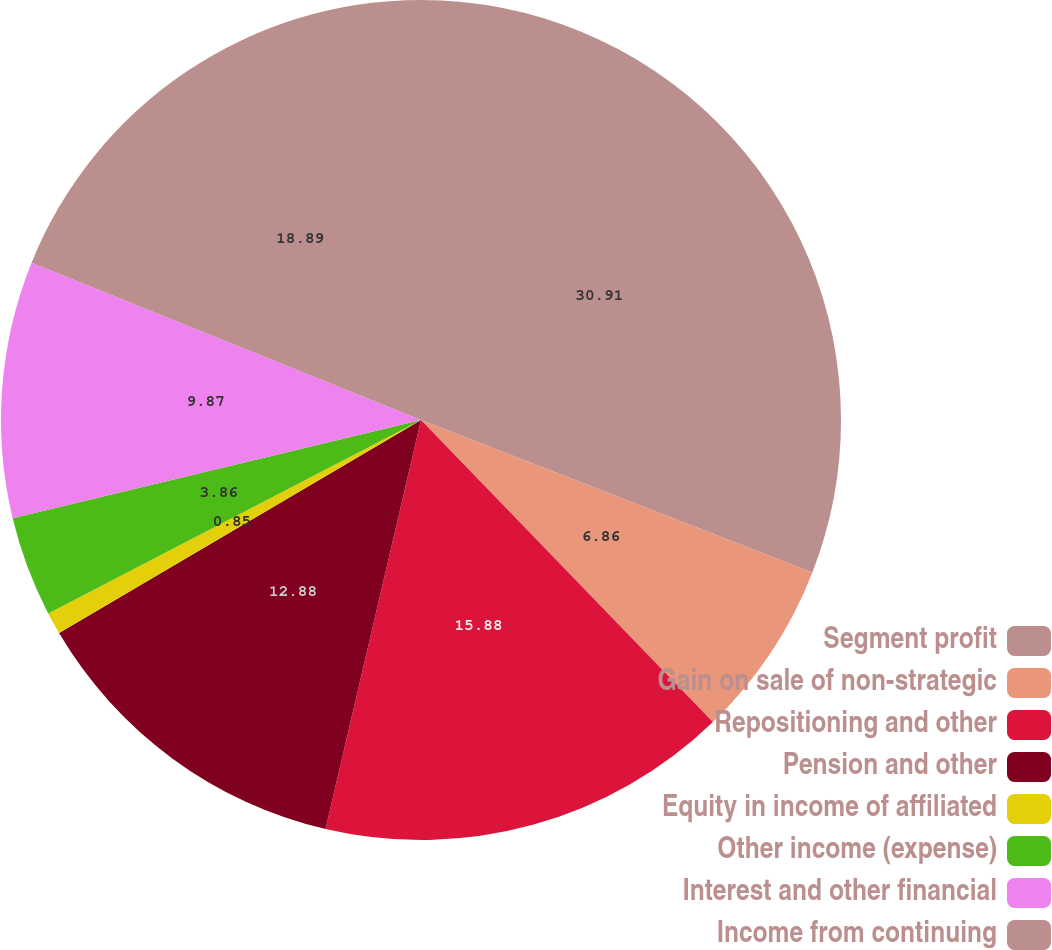Convert chart. <chart><loc_0><loc_0><loc_500><loc_500><pie_chart><fcel>Segment profit<fcel>Gain on sale of non-strategic<fcel>Repositioning and other<fcel>Pension and other<fcel>Equity in income of affiliated<fcel>Other income (expense)<fcel>Interest and other financial<fcel>Income from continuing<nl><fcel>30.91%<fcel>6.86%<fcel>15.88%<fcel>12.88%<fcel>0.85%<fcel>3.86%<fcel>9.87%<fcel>18.89%<nl></chart> 